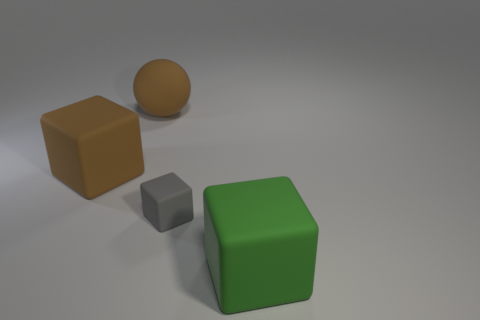What material is the ball that is the same size as the green rubber object?
Keep it short and to the point. Rubber. Is the color of the large matte block right of the gray block the same as the rubber object that is left of the big ball?
Your response must be concise. No. Is there a tiny blue metal object of the same shape as the small gray matte thing?
Your answer should be very brief. No. What shape is the green matte thing that is the same size as the brown cube?
Make the answer very short. Cube. What number of rubber spheres are the same color as the tiny object?
Ensure brevity in your answer.  0. There is a matte object to the right of the tiny gray rubber thing; how big is it?
Provide a succinct answer. Large. How many other things have the same size as the green object?
Provide a short and direct response. 2. What color is the ball that is the same material as the big brown block?
Make the answer very short. Brown. Are there fewer big brown rubber objects that are behind the small gray rubber block than tiny brown metal things?
Keep it short and to the point. No. There is a gray object that is the same material as the large brown ball; what is its shape?
Offer a terse response. Cube. 